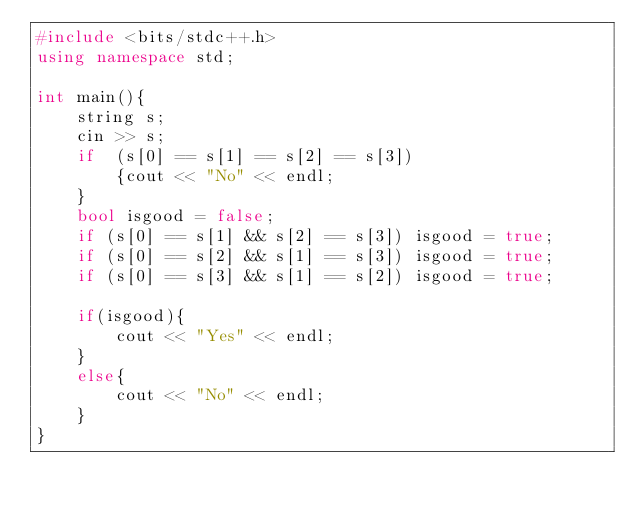Convert code to text. <code><loc_0><loc_0><loc_500><loc_500><_C++_>#include <bits/stdc++.h>
using namespace std;

int main(){
    string s;
    cin >> s;
    if  (s[0] == s[1] == s[2] == s[3]) 
        {cout << "No" << endl;
    }
    bool isgood = false;
    if (s[0] == s[1] && s[2] == s[3]) isgood = true;
    if (s[0] == s[2] && s[1] == s[3]) isgood = true;
    if (s[0] == s[3] && s[1] == s[2]) isgood = true;
    
    if(isgood){
        cout << "Yes" << endl;
    }
    else{
        cout << "No" << endl;
    }
}</code> 